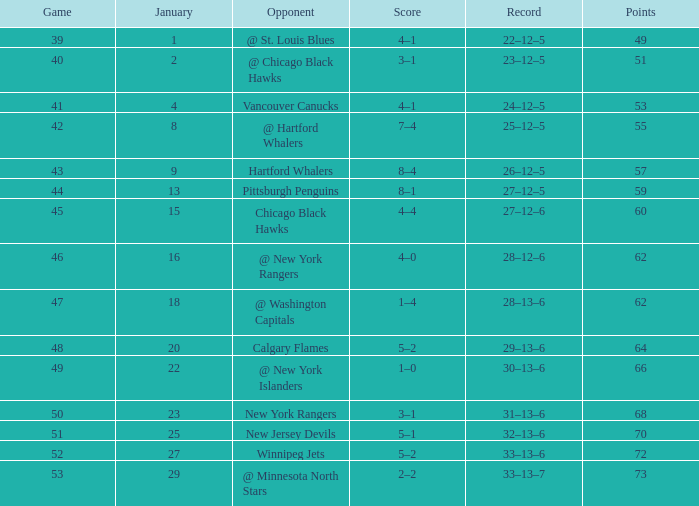In which january does a 7-4 score occur and a game with a size less than 42 take place? None. 